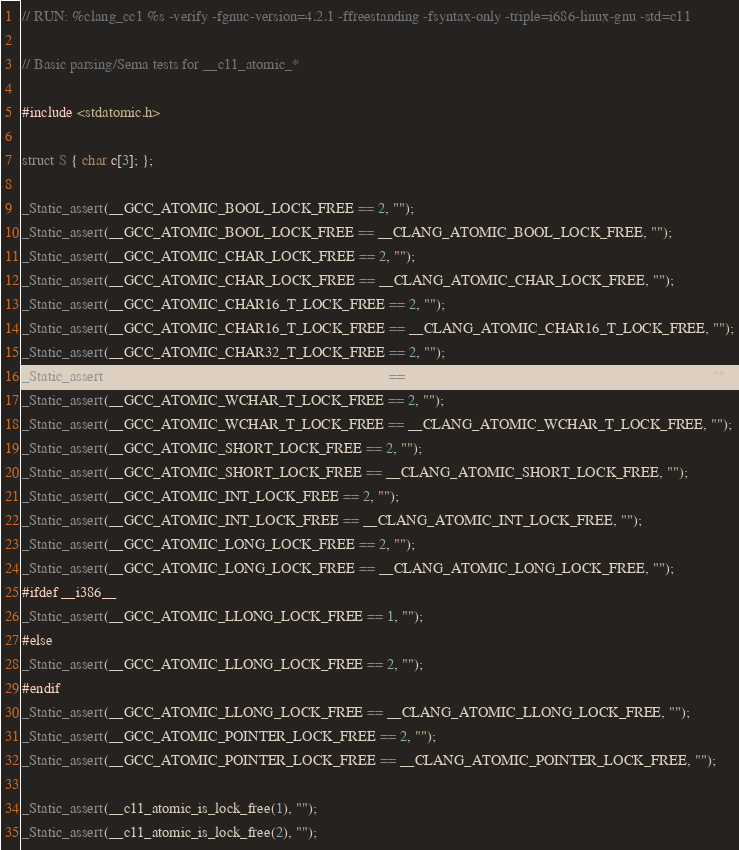Convert code to text. <code><loc_0><loc_0><loc_500><loc_500><_C_>// RUN: %clang_cc1 %s -verify -fgnuc-version=4.2.1 -ffreestanding -fsyntax-only -triple=i686-linux-gnu -std=c11

// Basic parsing/Sema tests for __c11_atomic_*

#include <stdatomic.h>

struct S { char c[3]; };

_Static_assert(__GCC_ATOMIC_BOOL_LOCK_FREE == 2, "");
_Static_assert(__GCC_ATOMIC_BOOL_LOCK_FREE == __CLANG_ATOMIC_BOOL_LOCK_FREE, "");
_Static_assert(__GCC_ATOMIC_CHAR_LOCK_FREE == 2, "");
_Static_assert(__GCC_ATOMIC_CHAR_LOCK_FREE == __CLANG_ATOMIC_CHAR_LOCK_FREE, "");
_Static_assert(__GCC_ATOMIC_CHAR16_T_LOCK_FREE == 2, "");
_Static_assert(__GCC_ATOMIC_CHAR16_T_LOCK_FREE == __CLANG_ATOMIC_CHAR16_T_LOCK_FREE, "");
_Static_assert(__GCC_ATOMIC_CHAR32_T_LOCK_FREE == 2, "");
_Static_assert(__GCC_ATOMIC_CHAR32_T_LOCK_FREE == __CLANG_ATOMIC_CHAR32_T_LOCK_FREE, "");
_Static_assert(__GCC_ATOMIC_WCHAR_T_LOCK_FREE == 2, "");
_Static_assert(__GCC_ATOMIC_WCHAR_T_LOCK_FREE == __CLANG_ATOMIC_WCHAR_T_LOCK_FREE, "");
_Static_assert(__GCC_ATOMIC_SHORT_LOCK_FREE == 2, "");
_Static_assert(__GCC_ATOMIC_SHORT_LOCK_FREE == __CLANG_ATOMIC_SHORT_LOCK_FREE, "");
_Static_assert(__GCC_ATOMIC_INT_LOCK_FREE == 2, "");
_Static_assert(__GCC_ATOMIC_INT_LOCK_FREE == __CLANG_ATOMIC_INT_LOCK_FREE, "");
_Static_assert(__GCC_ATOMIC_LONG_LOCK_FREE == 2, "");
_Static_assert(__GCC_ATOMIC_LONG_LOCK_FREE == __CLANG_ATOMIC_LONG_LOCK_FREE, "");
#ifdef __i386__
_Static_assert(__GCC_ATOMIC_LLONG_LOCK_FREE == 1, "");
#else
_Static_assert(__GCC_ATOMIC_LLONG_LOCK_FREE == 2, "");
#endif
_Static_assert(__GCC_ATOMIC_LLONG_LOCK_FREE == __CLANG_ATOMIC_LLONG_LOCK_FREE, "");
_Static_assert(__GCC_ATOMIC_POINTER_LOCK_FREE == 2, "");
_Static_assert(__GCC_ATOMIC_POINTER_LOCK_FREE == __CLANG_ATOMIC_POINTER_LOCK_FREE, "");

_Static_assert(__c11_atomic_is_lock_free(1), "");
_Static_assert(__c11_atomic_is_lock_free(2), "");</code> 